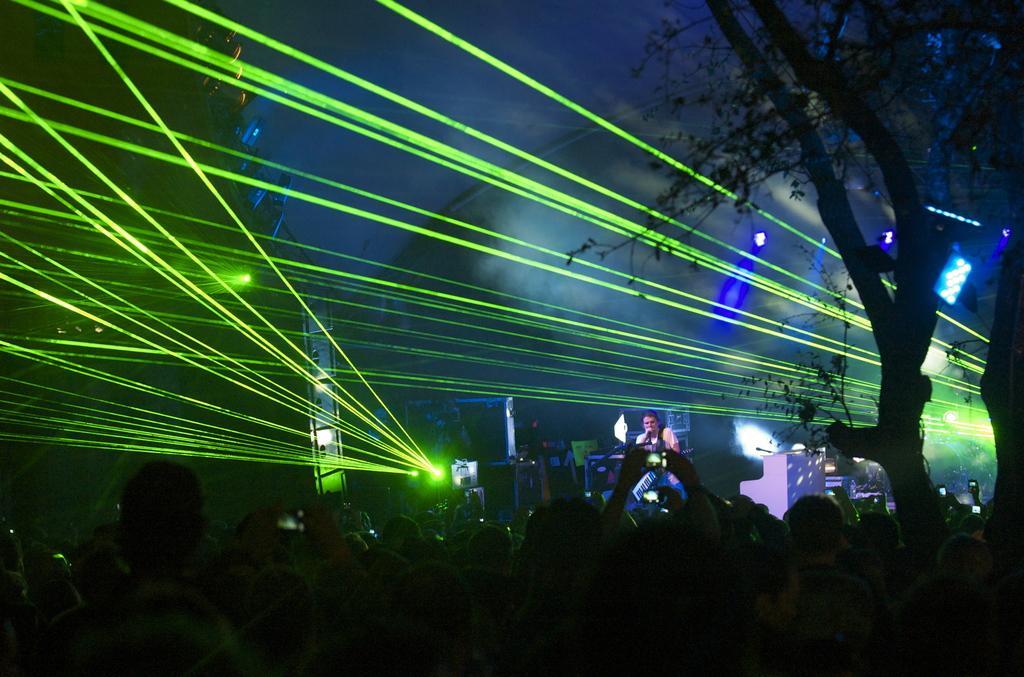Could you give a brief overview of what you see in this image? In this picture we can see a person on the stage, there is a microphone in front of him, at the bottom there are some people, we can see some lights in the background, on the right side there is a tree. 